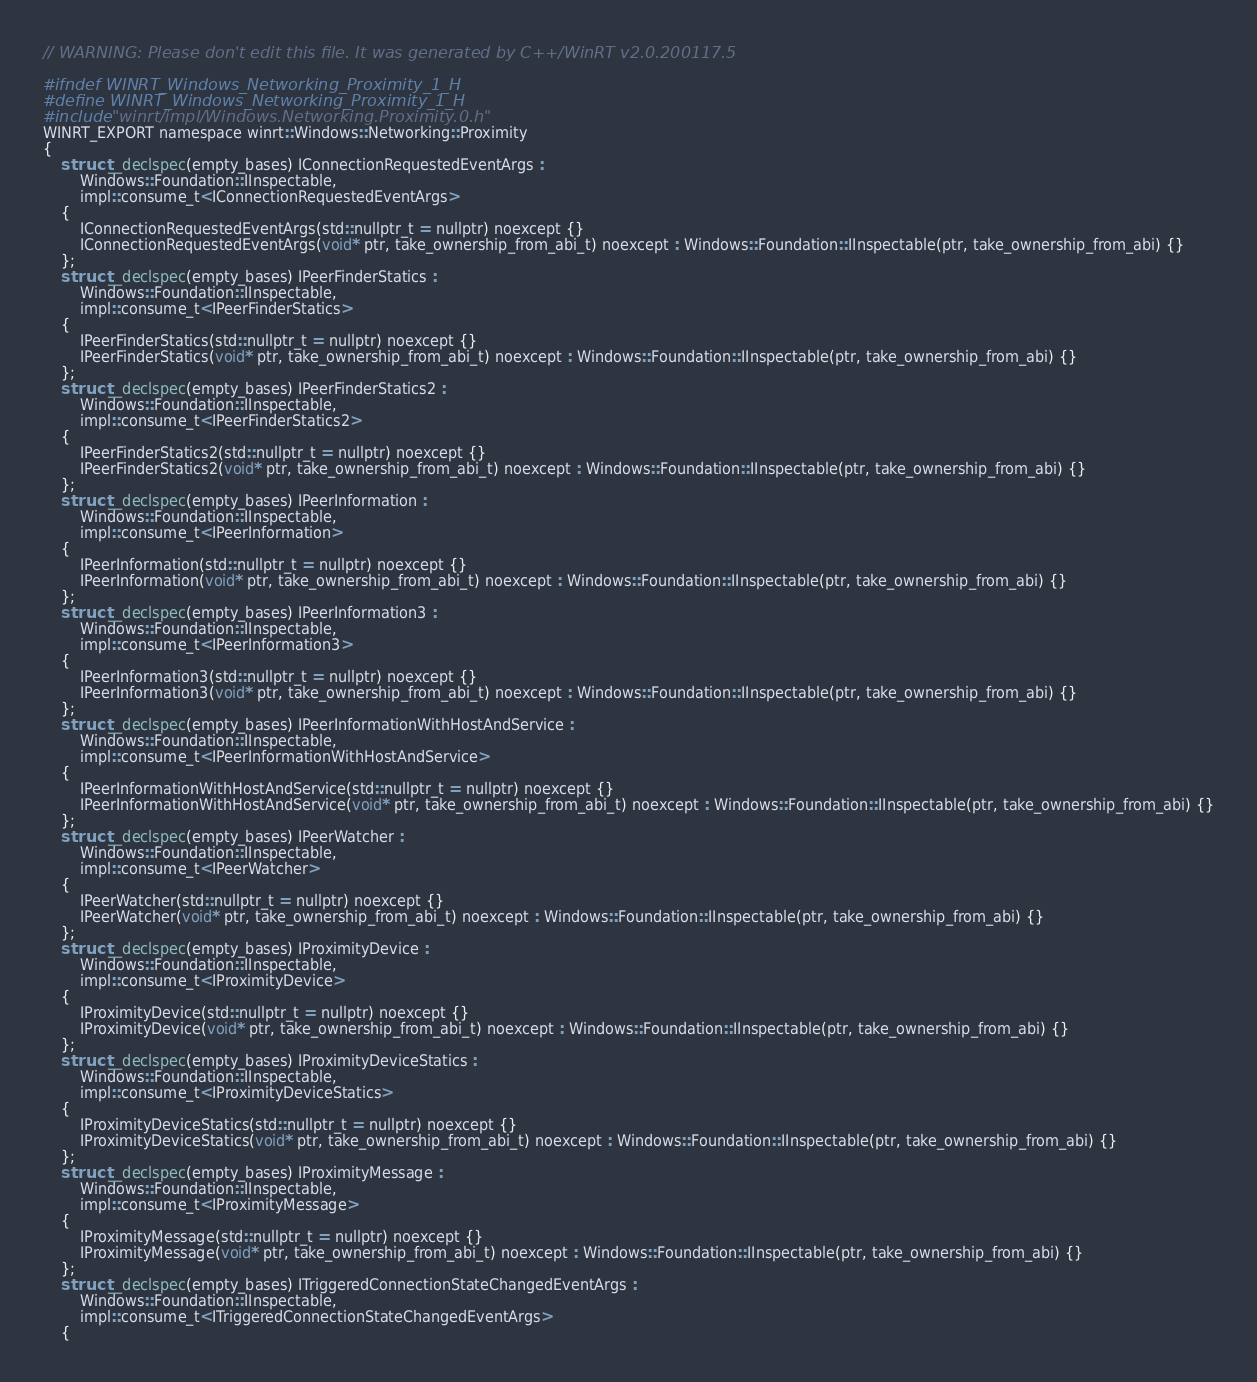Convert code to text. <code><loc_0><loc_0><loc_500><loc_500><_C_>// WARNING: Please don't edit this file. It was generated by C++/WinRT v2.0.200117.5

#ifndef WINRT_Windows_Networking_Proximity_1_H
#define WINRT_Windows_Networking_Proximity_1_H
#include "winrt/impl/Windows.Networking.Proximity.0.h"
WINRT_EXPORT namespace winrt::Windows::Networking::Proximity
{
    struct __declspec(empty_bases) IConnectionRequestedEventArgs :
        Windows::Foundation::IInspectable,
        impl::consume_t<IConnectionRequestedEventArgs>
    {
        IConnectionRequestedEventArgs(std::nullptr_t = nullptr) noexcept {}
        IConnectionRequestedEventArgs(void* ptr, take_ownership_from_abi_t) noexcept : Windows::Foundation::IInspectable(ptr, take_ownership_from_abi) {}
    };
    struct __declspec(empty_bases) IPeerFinderStatics :
        Windows::Foundation::IInspectable,
        impl::consume_t<IPeerFinderStatics>
    {
        IPeerFinderStatics(std::nullptr_t = nullptr) noexcept {}
        IPeerFinderStatics(void* ptr, take_ownership_from_abi_t) noexcept : Windows::Foundation::IInspectable(ptr, take_ownership_from_abi) {}
    };
    struct __declspec(empty_bases) IPeerFinderStatics2 :
        Windows::Foundation::IInspectable,
        impl::consume_t<IPeerFinderStatics2>
    {
        IPeerFinderStatics2(std::nullptr_t = nullptr) noexcept {}
        IPeerFinderStatics2(void* ptr, take_ownership_from_abi_t) noexcept : Windows::Foundation::IInspectable(ptr, take_ownership_from_abi) {}
    };
    struct __declspec(empty_bases) IPeerInformation :
        Windows::Foundation::IInspectable,
        impl::consume_t<IPeerInformation>
    {
        IPeerInformation(std::nullptr_t = nullptr) noexcept {}
        IPeerInformation(void* ptr, take_ownership_from_abi_t) noexcept : Windows::Foundation::IInspectable(ptr, take_ownership_from_abi) {}
    };
    struct __declspec(empty_bases) IPeerInformation3 :
        Windows::Foundation::IInspectable,
        impl::consume_t<IPeerInformation3>
    {
        IPeerInformation3(std::nullptr_t = nullptr) noexcept {}
        IPeerInformation3(void* ptr, take_ownership_from_abi_t) noexcept : Windows::Foundation::IInspectable(ptr, take_ownership_from_abi) {}
    };
    struct __declspec(empty_bases) IPeerInformationWithHostAndService :
        Windows::Foundation::IInspectable,
        impl::consume_t<IPeerInformationWithHostAndService>
    {
        IPeerInformationWithHostAndService(std::nullptr_t = nullptr) noexcept {}
        IPeerInformationWithHostAndService(void* ptr, take_ownership_from_abi_t) noexcept : Windows::Foundation::IInspectable(ptr, take_ownership_from_abi) {}
    };
    struct __declspec(empty_bases) IPeerWatcher :
        Windows::Foundation::IInspectable,
        impl::consume_t<IPeerWatcher>
    {
        IPeerWatcher(std::nullptr_t = nullptr) noexcept {}
        IPeerWatcher(void* ptr, take_ownership_from_abi_t) noexcept : Windows::Foundation::IInspectable(ptr, take_ownership_from_abi) {}
    };
    struct __declspec(empty_bases) IProximityDevice :
        Windows::Foundation::IInspectable,
        impl::consume_t<IProximityDevice>
    {
        IProximityDevice(std::nullptr_t = nullptr) noexcept {}
        IProximityDevice(void* ptr, take_ownership_from_abi_t) noexcept : Windows::Foundation::IInspectable(ptr, take_ownership_from_abi) {}
    };
    struct __declspec(empty_bases) IProximityDeviceStatics :
        Windows::Foundation::IInspectable,
        impl::consume_t<IProximityDeviceStatics>
    {
        IProximityDeviceStatics(std::nullptr_t = nullptr) noexcept {}
        IProximityDeviceStatics(void* ptr, take_ownership_from_abi_t) noexcept : Windows::Foundation::IInspectable(ptr, take_ownership_from_abi) {}
    };
    struct __declspec(empty_bases) IProximityMessage :
        Windows::Foundation::IInspectable,
        impl::consume_t<IProximityMessage>
    {
        IProximityMessage(std::nullptr_t = nullptr) noexcept {}
        IProximityMessage(void* ptr, take_ownership_from_abi_t) noexcept : Windows::Foundation::IInspectable(ptr, take_ownership_from_abi) {}
    };
    struct __declspec(empty_bases) ITriggeredConnectionStateChangedEventArgs :
        Windows::Foundation::IInspectable,
        impl::consume_t<ITriggeredConnectionStateChangedEventArgs>
    {</code> 